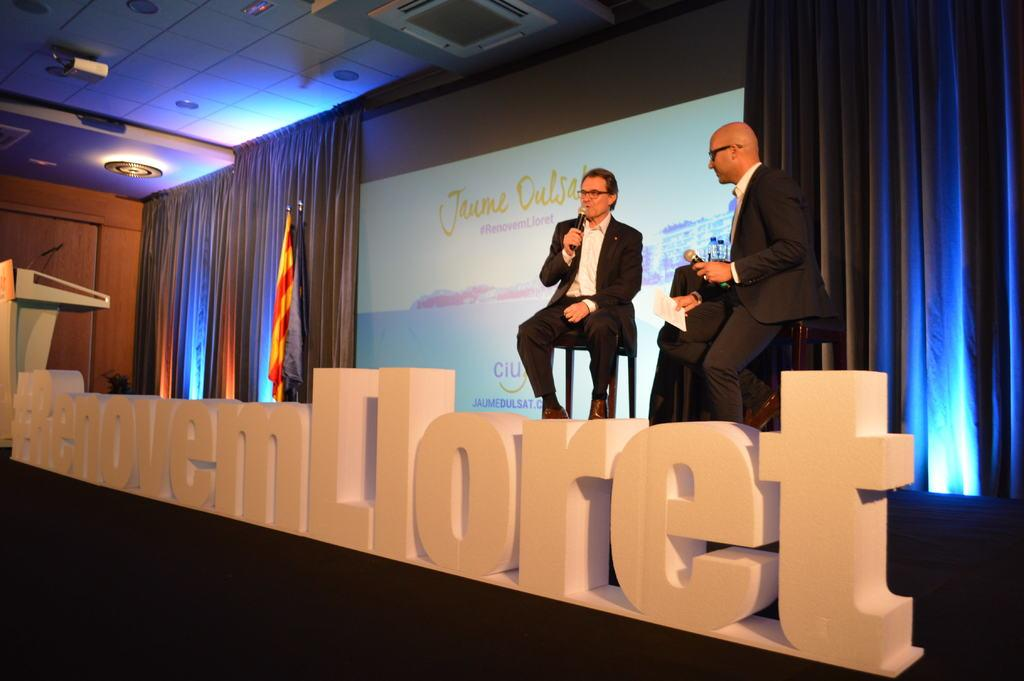Provide a one-sentence caption for the provided image. Two men standing over a large hash tag sign. 